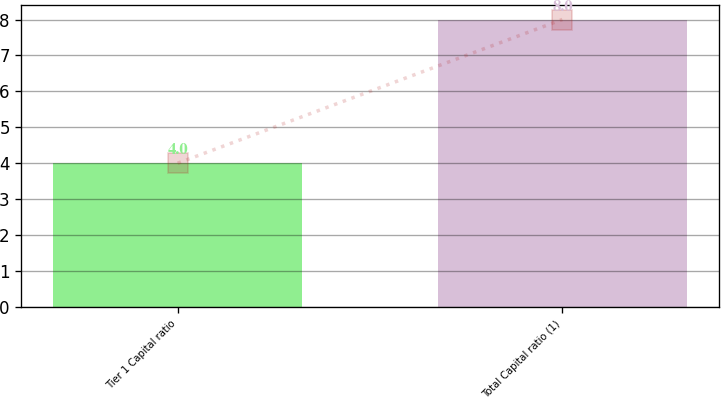Convert chart to OTSL. <chart><loc_0><loc_0><loc_500><loc_500><bar_chart><fcel>Tier 1 Capital ratio<fcel>Total Capital ratio (1)<nl><fcel>4<fcel>8<nl></chart> 